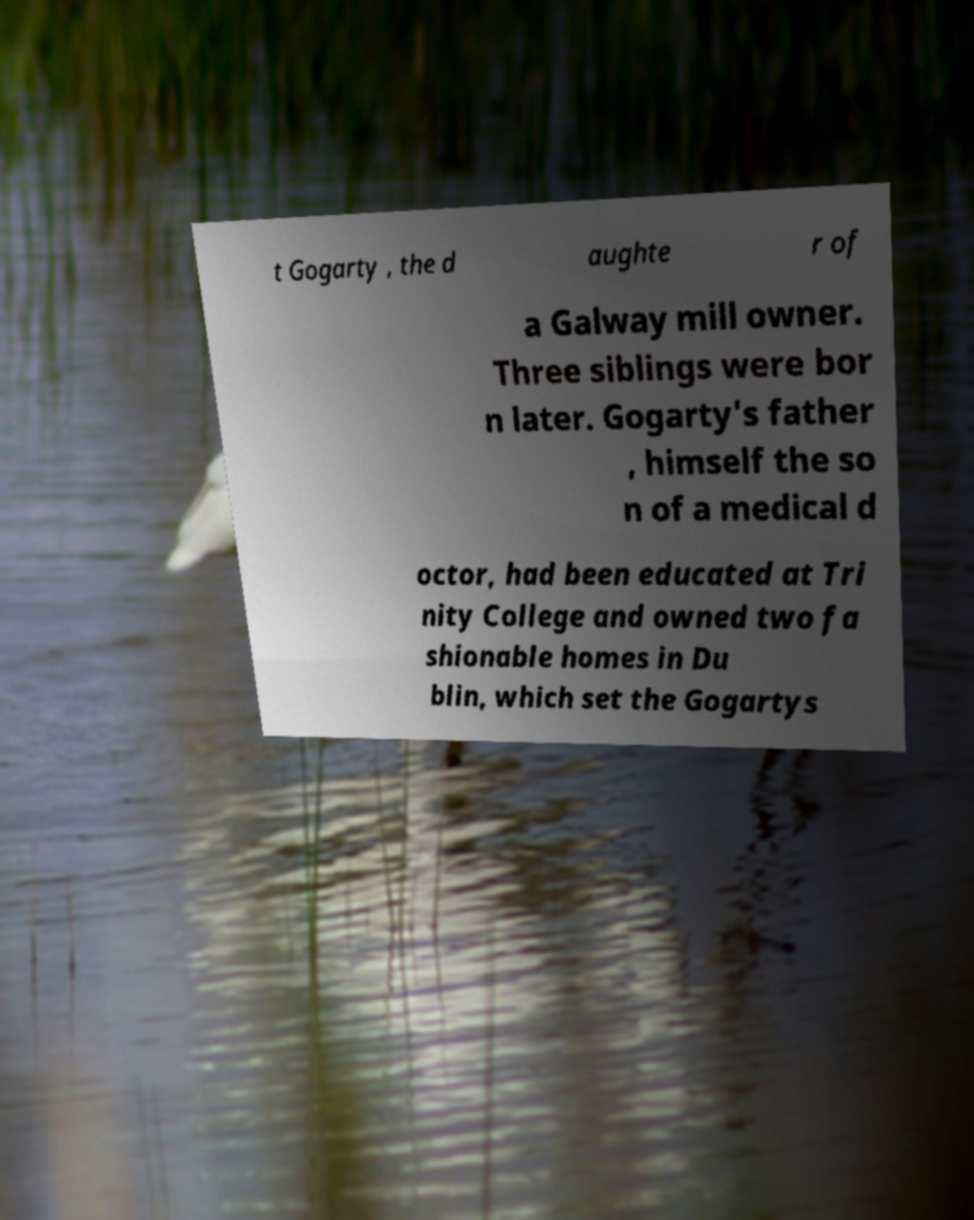What messages or text are displayed in this image? I need them in a readable, typed format. t Gogarty , the d aughte r of a Galway mill owner. Three siblings were bor n later. Gogarty's father , himself the so n of a medical d octor, had been educated at Tri nity College and owned two fa shionable homes in Du blin, which set the Gogartys 